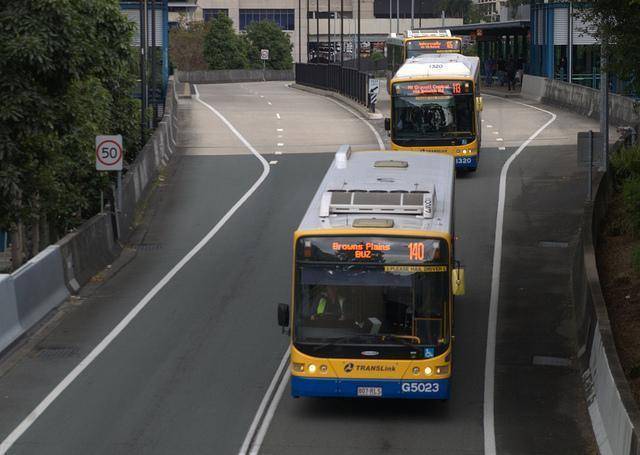How many buses are visible?
Give a very brief answer. 2. 